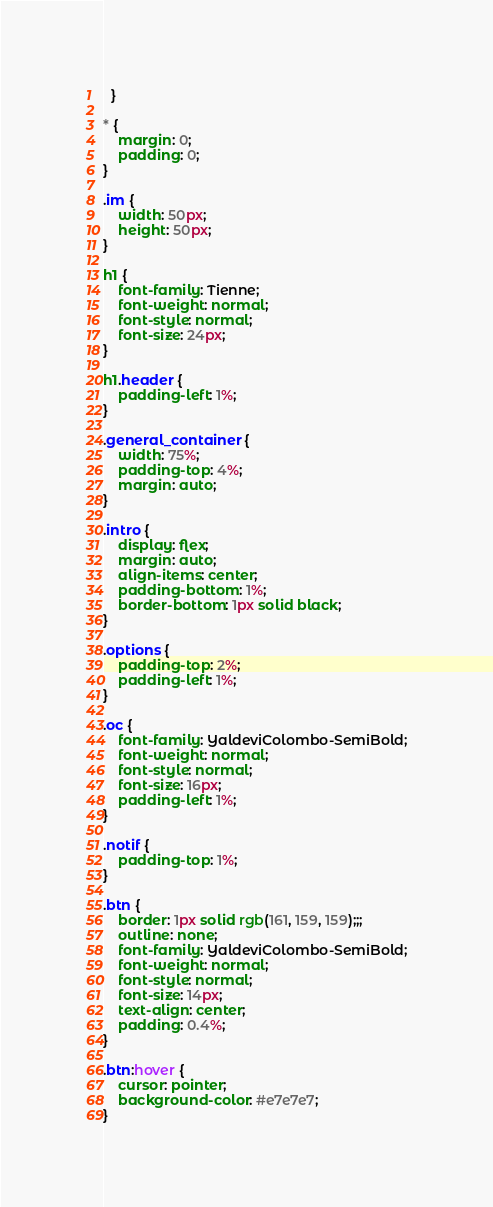<code> <loc_0><loc_0><loc_500><loc_500><_CSS_>  }

* {
    margin: 0;
    padding: 0;
}

.im {
    width: 50px;
    height: 50px;
}

h1 {
    font-family: Tienne;
    font-weight: normal;
    font-style: normal;
    font-size: 24px;
}

h1.header {
    padding-left: 1%;
}

.general_container {
    width: 75%;
    padding-top: 4%;  
    margin: auto;
}

.intro {
    display: flex;
    margin: auto;
    align-items: center;
    padding-bottom: 1%;
    border-bottom: 1px solid black;
}

.options {
    padding-top: 2%;
    padding-left: 1%;
}

.oc {
    font-family: YaldeviColombo-SemiBold;
    font-weight: normal;
    font-style: normal;
    font-size: 16px;
    padding-left: 1%;
}

.notif {
    padding-top: 1%;
}

.btn {
    border: 1px solid rgb(161, 159, 159);;; 
    outline: none;
    font-family: YaldeviColombo-SemiBold;
    font-weight: normal;
    font-style: normal;
    font-size: 14px;
    text-align: center;
    padding: 0.4%;
}

.btn:hover {
    cursor: pointer;
    background-color: #e7e7e7;
}
</code> 